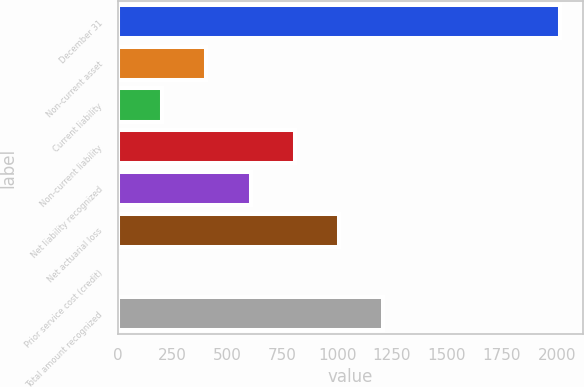Convert chart. <chart><loc_0><loc_0><loc_500><loc_500><bar_chart><fcel>December 31<fcel>Non-current asset<fcel>Current liability<fcel>Non-current liability<fcel>Net liability recognized<fcel>Net actuarial loss<fcel>Prior service cost (credit)<fcel>Total amount recognized<nl><fcel>2017<fcel>404.28<fcel>202.69<fcel>807.46<fcel>605.87<fcel>1009.05<fcel>1.1<fcel>1210.64<nl></chart> 